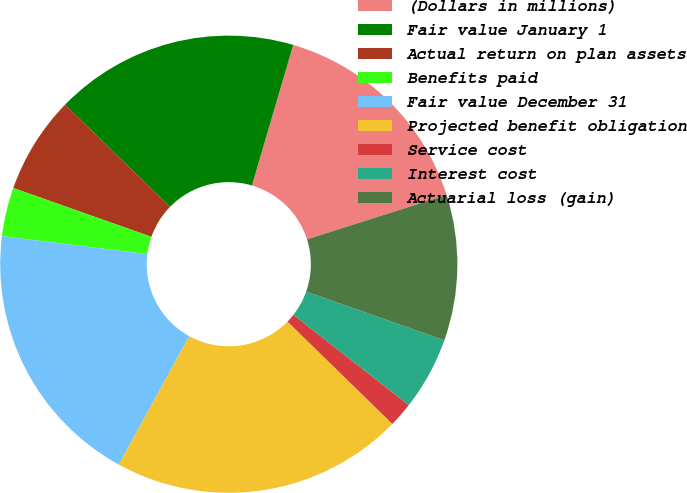Convert chart. <chart><loc_0><loc_0><loc_500><loc_500><pie_chart><fcel>(Dollars in millions)<fcel>Fair value January 1<fcel>Actual return on plan assets<fcel>Benefits paid<fcel>Fair value December 31<fcel>Projected benefit obligation<fcel>Service cost<fcel>Interest cost<fcel>Actuarial loss (gain)<nl><fcel>15.55%<fcel>17.26%<fcel>6.88%<fcel>3.45%<fcel>18.97%<fcel>20.68%<fcel>1.74%<fcel>5.17%<fcel>10.3%<nl></chart> 